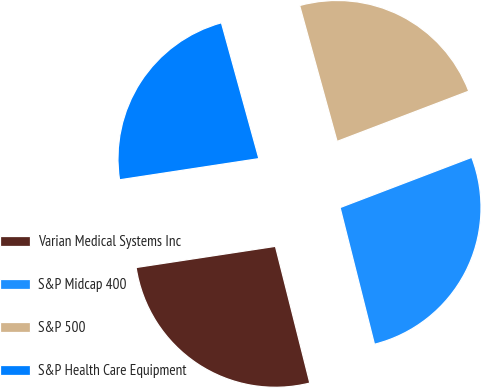<chart> <loc_0><loc_0><loc_500><loc_500><pie_chart><fcel>Varian Medical Systems Inc<fcel>S&P Midcap 400<fcel>S&P 500<fcel>S&P Health Care Equipment<nl><fcel>26.52%<fcel>26.88%<fcel>23.48%<fcel>23.12%<nl></chart> 